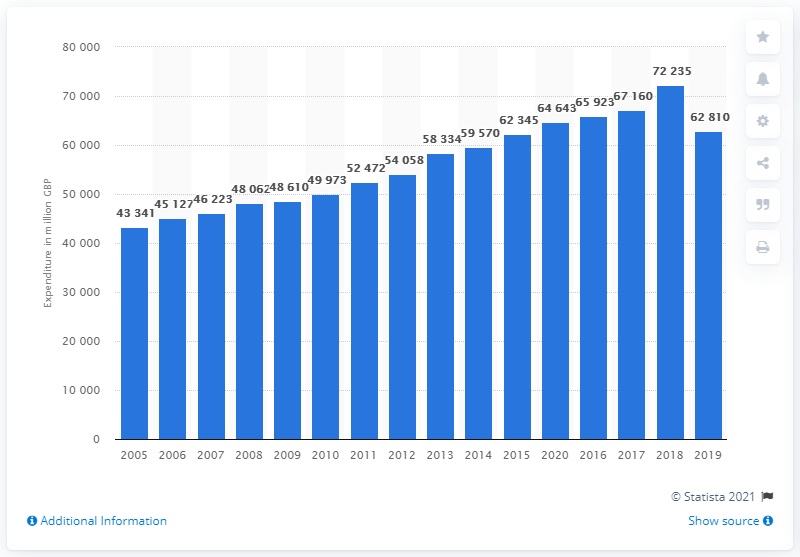What is the estimated value of the UK's apparel and footwear market? The estimated value of the UK's apparel and footwear market in recent years shows a fluctuating trend with an overall increase. The latest figure available on the chart for 2019 indicates a market value of approximately 62.81 billion GBP. This reflects an increase from previous years, with the market value seeing a peak around 2018. It is essential to consider industry reports for the most current figures as market conditions can change rapidly. 